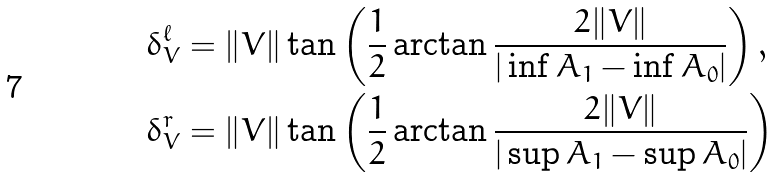<formula> <loc_0><loc_0><loc_500><loc_500>\delta _ { V } ^ { \ell } & = \| V \| \tan \left ( \frac { 1 } { 2 } \arctan \frac { 2 \| V \| } { | \inf A _ { 1 } - \inf A _ { 0 } | } \right ) , \\ \delta _ { V } ^ { r } & = \| V \| \tan \left ( \frac { 1 } { 2 } \arctan \frac { 2 \| V \| } { | \sup A _ { 1 } - \sup A _ { 0 } | } \right )</formula> 